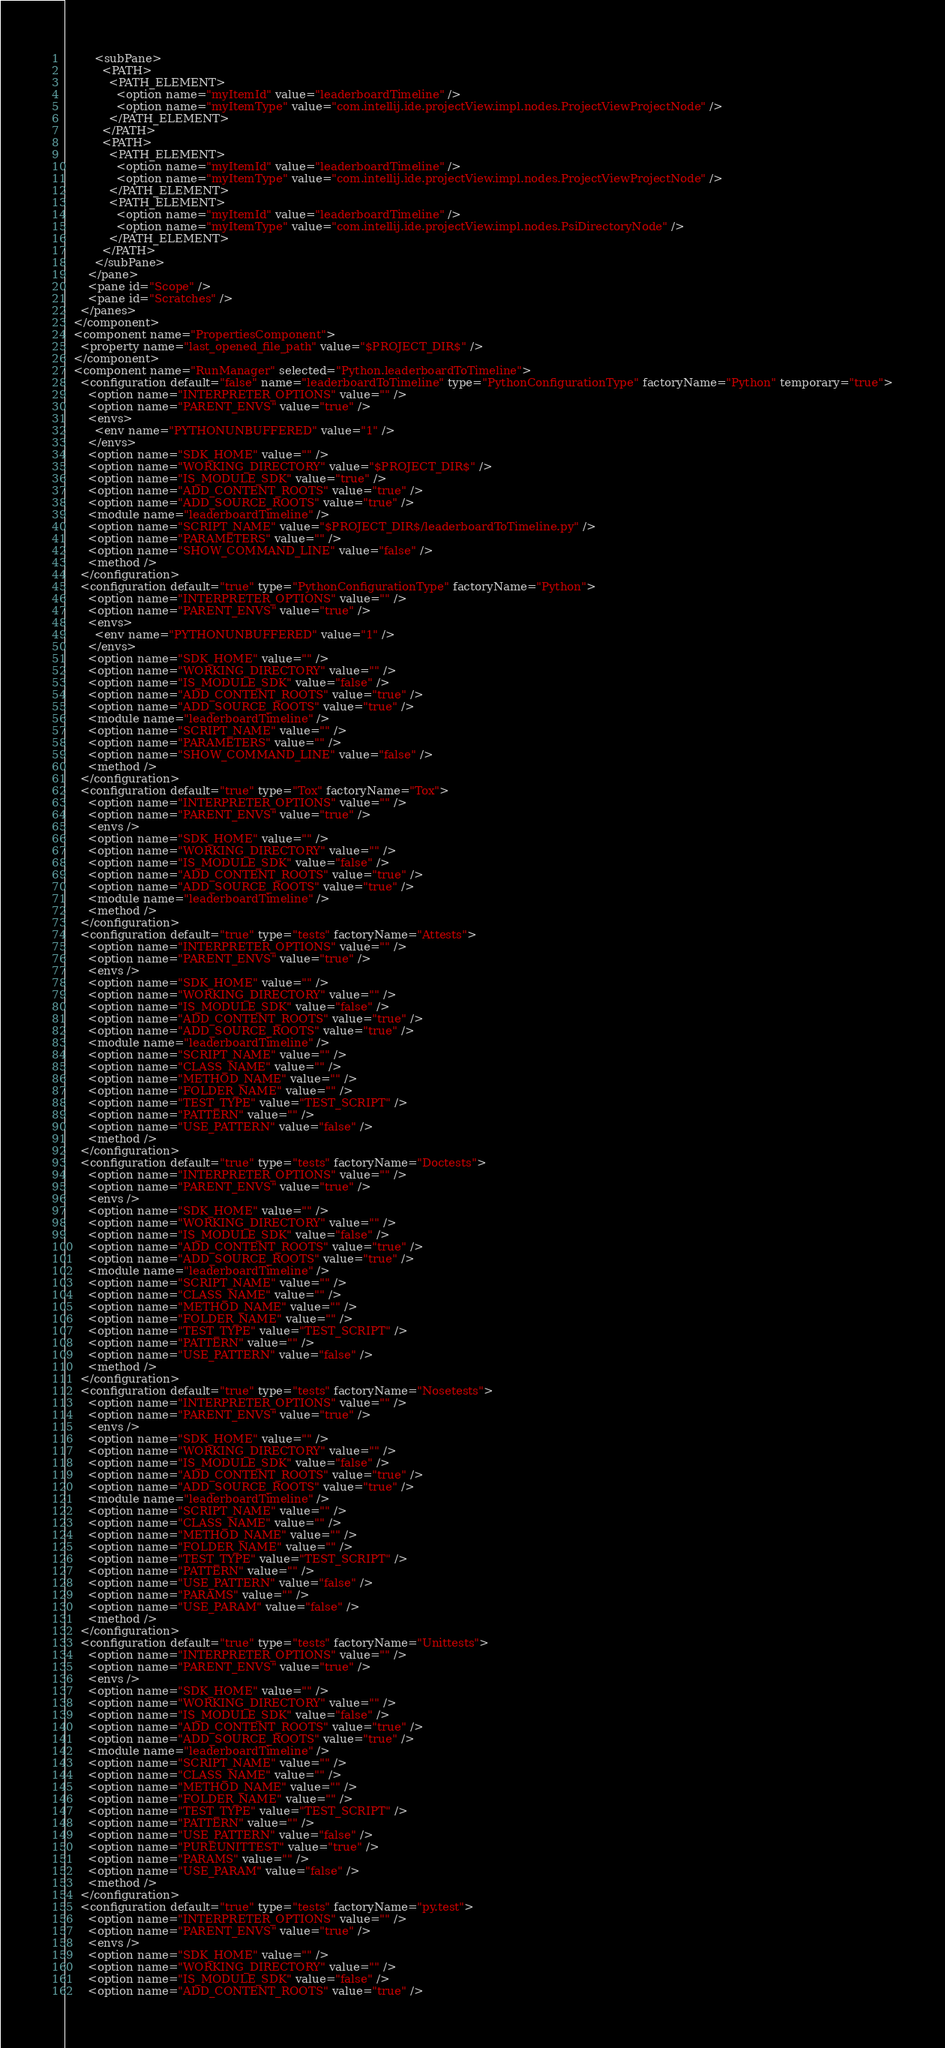Convert code to text. <code><loc_0><loc_0><loc_500><loc_500><_XML_>        <subPane>
          <PATH>
            <PATH_ELEMENT>
              <option name="myItemId" value="leaderboardTimeline" />
              <option name="myItemType" value="com.intellij.ide.projectView.impl.nodes.ProjectViewProjectNode" />
            </PATH_ELEMENT>
          </PATH>
          <PATH>
            <PATH_ELEMENT>
              <option name="myItemId" value="leaderboardTimeline" />
              <option name="myItemType" value="com.intellij.ide.projectView.impl.nodes.ProjectViewProjectNode" />
            </PATH_ELEMENT>
            <PATH_ELEMENT>
              <option name="myItemId" value="leaderboardTimeline" />
              <option name="myItemType" value="com.intellij.ide.projectView.impl.nodes.PsiDirectoryNode" />
            </PATH_ELEMENT>
          </PATH>
        </subPane>
      </pane>
      <pane id="Scope" />
      <pane id="Scratches" />
    </panes>
  </component>
  <component name="PropertiesComponent">
    <property name="last_opened_file_path" value="$PROJECT_DIR$" />
  </component>
  <component name="RunManager" selected="Python.leaderboardToTimeline">
    <configuration default="false" name="leaderboardToTimeline" type="PythonConfigurationType" factoryName="Python" temporary="true">
      <option name="INTERPRETER_OPTIONS" value="" />
      <option name="PARENT_ENVS" value="true" />
      <envs>
        <env name="PYTHONUNBUFFERED" value="1" />
      </envs>
      <option name="SDK_HOME" value="" />
      <option name="WORKING_DIRECTORY" value="$PROJECT_DIR$" />
      <option name="IS_MODULE_SDK" value="true" />
      <option name="ADD_CONTENT_ROOTS" value="true" />
      <option name="ADD_SOURCE_ROOTS" value="true" />
      <module name="leaderboardTimeline" />
      <option name="SCRIPT_NAME" value="$PROJECT_DIR$/leaderboardToTimeline.py" />
      <option name="PARAMETERS" value="" />
      <option name="SHOW_COMMAND_LINE" value="false" />
      <method />
    </configuration>
    <configuration default="true" type="PythonConfigurationType" factoryName="Python">
      <option name="INTERPRETER_OPTIONS" value="" />
      <option name="PARENT_ENVS" value="true" />
      <envs>
        <env name="PYTHONUNBUFFERED" value="1" />
      </envs>
      <option name="SDK_HOME" value="" />
      <option name="WORKING_DIRECTORY" value="" />
      <option name="IS_MODULE_SDK" value="false" />
      <option name="ADD_CONTENT_ROOTS" value="true" />
      <option name="ADD_SOURCE_ROOTS" value="true" />
      <module name="leaderboardTimeline" />
      <option name="SCRIPT_NAME" value="" />
      <option name="PARAMETERS" value="" />
      <option name="SHOW_COMMAND_LINE" value="false" />
      <method />
    </configuration>
    <configuration default="true" type="Tox" factoryName="Tox">
      <option name="INTERPRETER_OPTIONS" value="" />
      <option name="PARENT_ENVS" value="true" />
      <envs />
      <option name="SDK_HOME" value="" />
      <option name="WORKING_DIRECTORY" value="" />
      <option name="IS_MODULE_SDK" value="false" />
      <option name="ADD_CONTENT_ROOTS" value="true" />
      <option name="ADD_SOURCE_ROOTS" value="true" />
      <module name="leaderboardTimeline" />
      <method />
    </configuration>
    <configuration default="true" type="tests" factoryName="Attests">
      <option name="INTERPRETER_OPTIONS" value="" />
      <option name="PARENT_ENVS" value="true" />
      <envs />
      <option name="SDK_HOME" value="" />
      <option name="WORKING_DIRECTORY" value="" />
      <option name="IS_MODULE_SDK" value="false" />
      <option name="ADD_CONTENT_ROOTS" value="true" />
      <option name="ADD_SOURCE_ROOTS" value="true" />
      <module name="leaderboardTimeline" />
      <option name="SCRIPT_NAME" value="" />
      <option name="CLASS_NAME" value="" />
      <option name="METHOD_NAME" value="" />
      <option name="FOLDER_NAME" value="" />
      <option name="TEST_TYPE" value="TEST_SCRIPT" />
      <option name="PATTERN" value="" />
      <option name="USE_PATTERN" value="false" />
      <method />
    </configuration>
    <configuration default="true" type="tests" factoryName="Doctests">
      <option name="INTERPRETER_OPTIONS" value="" />
      <option name="PARENT_ENVS" value="true" />
      <envs />
      <option name="SDK_HOME" value="" />
      <option name="WORKING_DIRECTORY" value="" />
      <option name="IS_MODULE_SDK" value="false" />
      <option name="ADD_CONTENT_ROOTS" value="true" />
      <option name="ADD_SOURCE_ROOTS" value="true" />
      <module name="leaderboardTimeline" />
      <option name="SCRIPT_NAME" value="" />
      <option name="CLASS_NAME" value="" />
      <option name="METHOD_NAME" value="" />
      <option name="FOLDER_NAME" value="" />
      <option name="TEST_TYPE" value="TEST_SCRIPT" />
      <option name="PATTERN" value="" />
      <option name="USE_PATTERN" value="false" />
      <method />
    </configuration>
    <configuration default="true" type="tests" factoryName="Nosetests">
      <option name="INTERPRETER_OPTIONS" value="" />
      <option name="PARENT_ENVS" value="true" />
      <envs />
      <option name="SDK_HOME" value="" />
      <option name="WORKING_DIRECTORY" value="" />
      <option name="IS_MODULE_SDK" value="false" />
      <option name="ADD_CONTENT_ROOTS" value="true" />
      <option name="ADD_SOURCE_ROOTS" value="true" />
      <module name="leaderboardTimeline" />
      <option name="SCRIPT_NAME" value="" />
      <option name="CLASS_NAME" value="" />
      <option name="METHOD_NAME" value="" />
      <option name="FOLDER_NAME" value="" />
      <option name="TEST_TYPE" value="TEST_SCRIPT" />
      <option name="PATTERN" value="" />
      <option name="USE_PATTERN" value="false" />
      <option name="PARAMS" value="" />
      <option name="USE_PARAM" value="false" />
      <method />
    </configuration>
    <configuration default="true" type="tests" factoryName="Unittests">
      <option name="INTERPRETER_OPTIONS" value="" />
      <option name="PARENT_ENVS" value="true" />
      <envs />
      <option name="SDK_HOME" value="" />
      <option name="WORKING_DIRECTORY" value="" />
      <option name="IS_MODULE_SDK" value="false" />
      <option name="ADD_CONTENT_ROOTS" value="true" />
      <option name="ADD_SOURCE_ROOTS" value="true" />
      <module name="leaderboardTimeline" />
      <option name="SCRIPT_NAME" value="" />
      <option name="CLASS_NAME" value="" />
      <option name="METHOD_NAME" value="" />
      <option name="FOLDER_NAME" value="" />
      <option name="TEST_TYPE" value="TEST_SCRIPT" />
      <option name="PATTERN" value="" />
      <option name="USE_PATTERN" value="false" />
      <option name="PUREUNITTEST" value="true" />
      <option name="PARAMS" value="" />
      <option name="USE_PARAM" value="false" />
      <method />
    </configuration>
    <configuration default="true" type="tests" factoryName="py.test">
      <option name="INTERPRETER_OPTIONS" value="" />
      <option name="PARENT_ENVS" value="true" />
      <envs />
      <option name="SDK_HOME" value="" />
      <option name="WORKING_DIRECTORY" value="" />
      <option name="IS_MODULE_SDK" value="false" />
      <option name="ADD_CONTENT_ROOTS" value="true" /></code> 